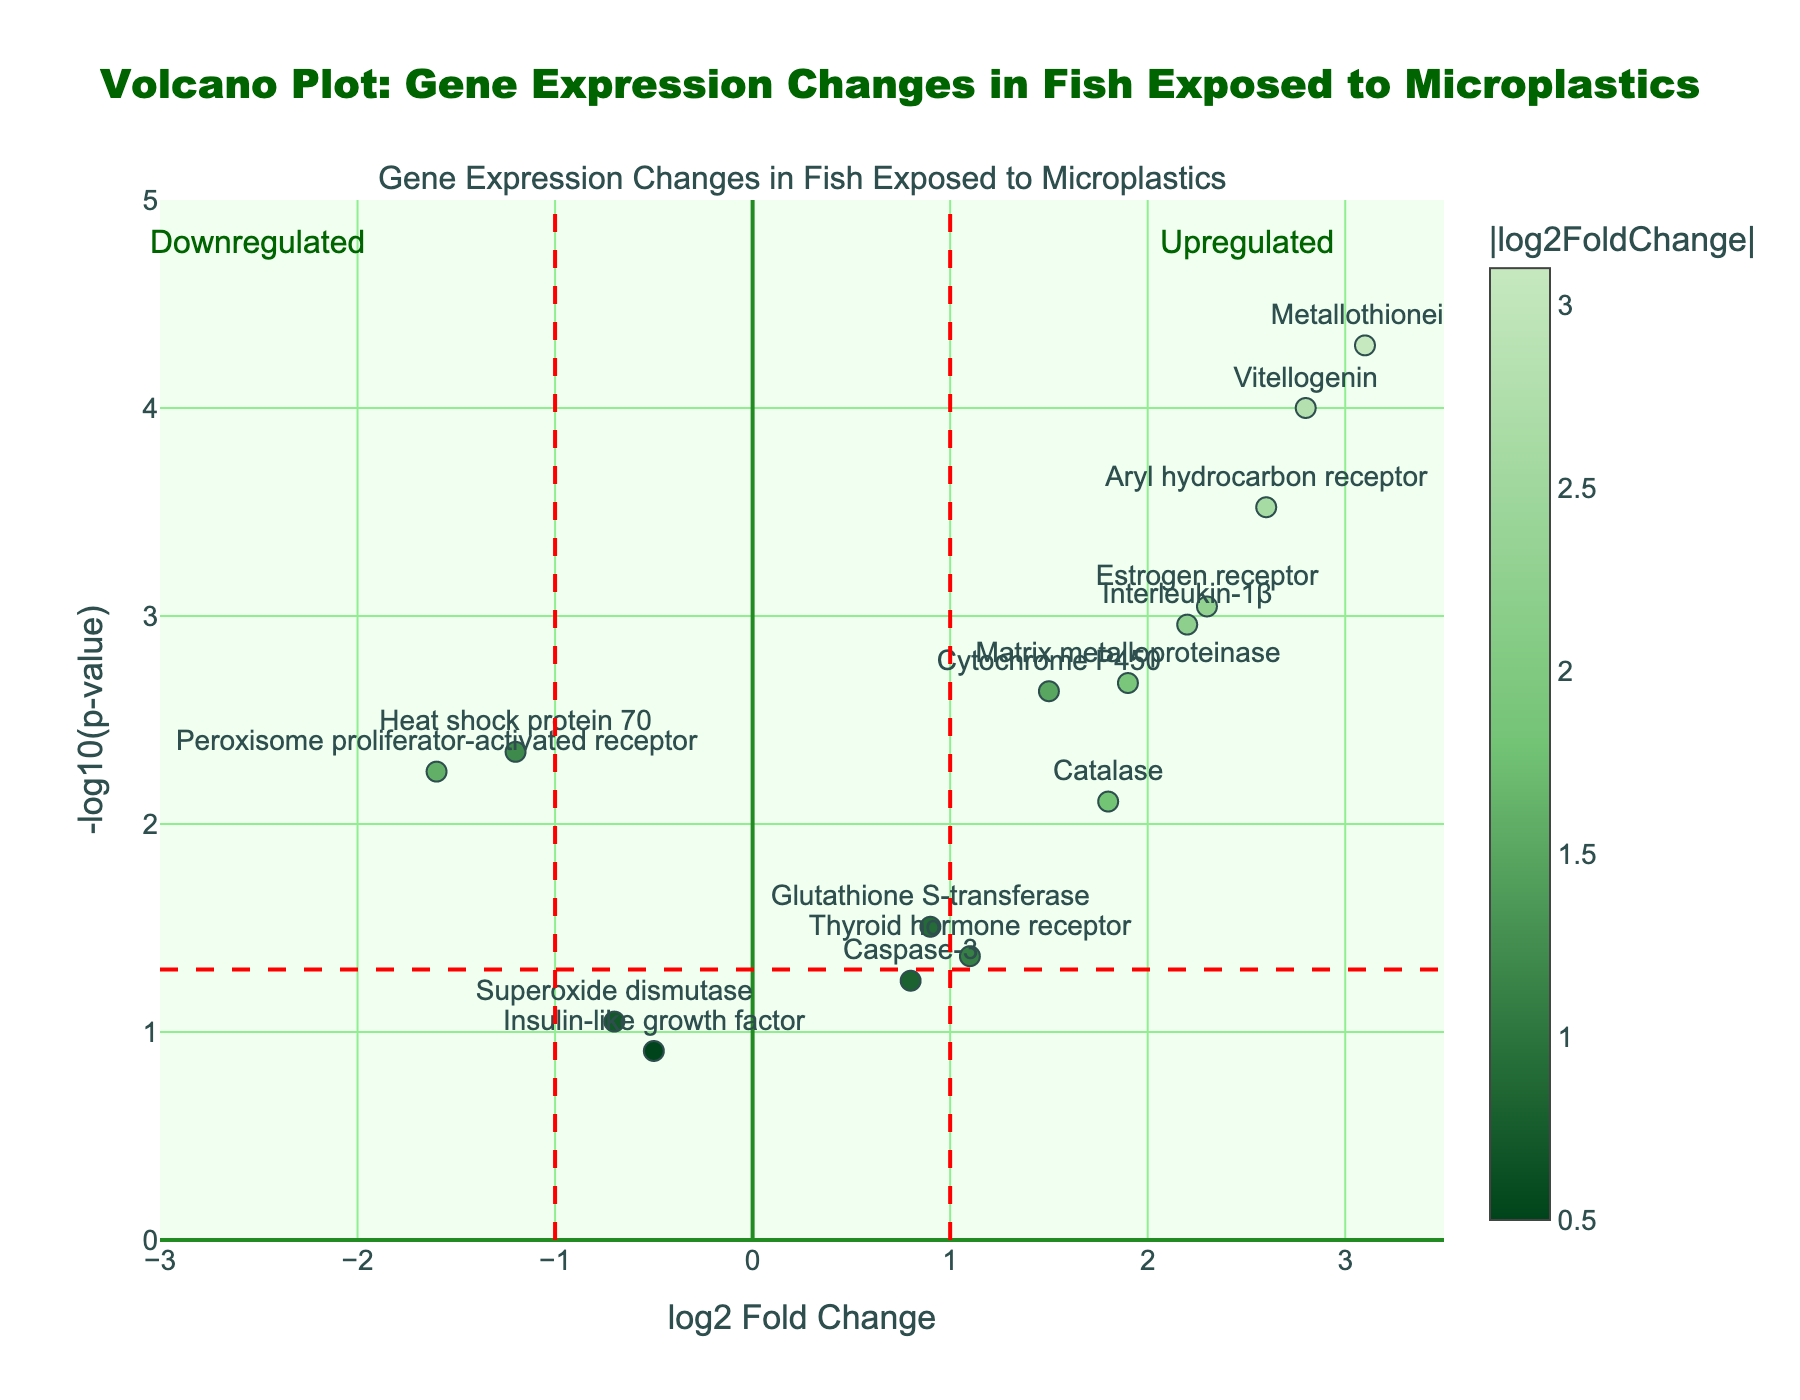What's the main title of the plot? The title is clearly displayed at the top of the plot.
Answer: Volcano Plot: Gene Expression Changes in Fish Exposed to Microplastics How many genes have their names displayed on the plot? Count the names shown next to the individual points on the plot.
Answer: 15 Which gene exhibits the highest log2 Fold Change? Identify the point farthest to the right on the x-axis and check the label for that gene.
Answer: Metallothionein What is the log2 Fold Change and p-value for the 'Heat shock protein 70' gene? Locate the 'Heat shock protein 70' label, then read off log2 Fold Change from the x-axis and p-value from the y-axis.
Answer: -1.2, 0.0045 Are there any genes with a -log10(p-value) above 4? Look for points above the y-axis value of 4 and check the respective labels.
Answer: Yes, Vitellogenin and Metallothionein Which gene is closest to the reference line at log2 Fold Change of 1? Locate the reference line at x=1 and find the nearest point with the gene label.
Answer: Thyroid hormone receptor How many genes have a log2 Fold Change greater than 2? Identify all points to the right of x=2 and count the respective gene labels.
Answer: 3 What does the red horizontal reference line indicate in terms of p-value? Understand that the y-axis is -log10(p-value). Convert the y-value where the line is drawn to a p-value.
Answer: -log10(0.05) Among the genes labeled, which one has the least significant p-value? Find the point with the lowest y-axis value identified by -log10(p-value) and read the gene label.
Answer: Insulin-like growth factor Which genes are classified as upregulated and downregulated if the threshold for log2 Fold Change is set at ±1? Identify points to the right of x=1 as upregulated and to the left of x=-1 as downregulated.
Answer: Upregulated: Vitellogenin, Metallothionein, Catalase, Estrogen receptor, Aryl hydrocarbon receptor, Interleukin-1β; Downregulated: Heat shock protein 70, Peroxisome proliferator-activated receptor 